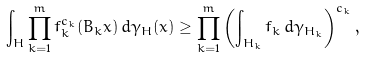<formula> <loc_0><loc_0><loc_500><loc_500>\int _ { H } \prod _ { k = 1 } ^ { m } f _ { k } ^ { c _ { k } } ( B _ { k } x ) \, d \gamma _ { H } ( x ) \geq \prod _ { k = 1 } ^ { m } \left ( \int _ { H _ { k } } f _ { k } \, d \gamma _ { H _ { k } } \right ) ^ { c _ { k } } ,</formula> 